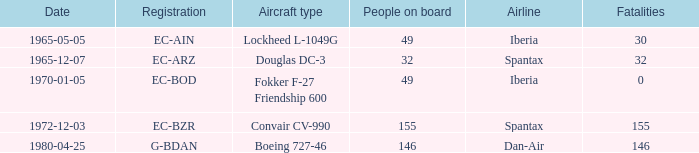How many fatalities are there for the airline of spantax, with a registration of ec-arz? 32.0. 